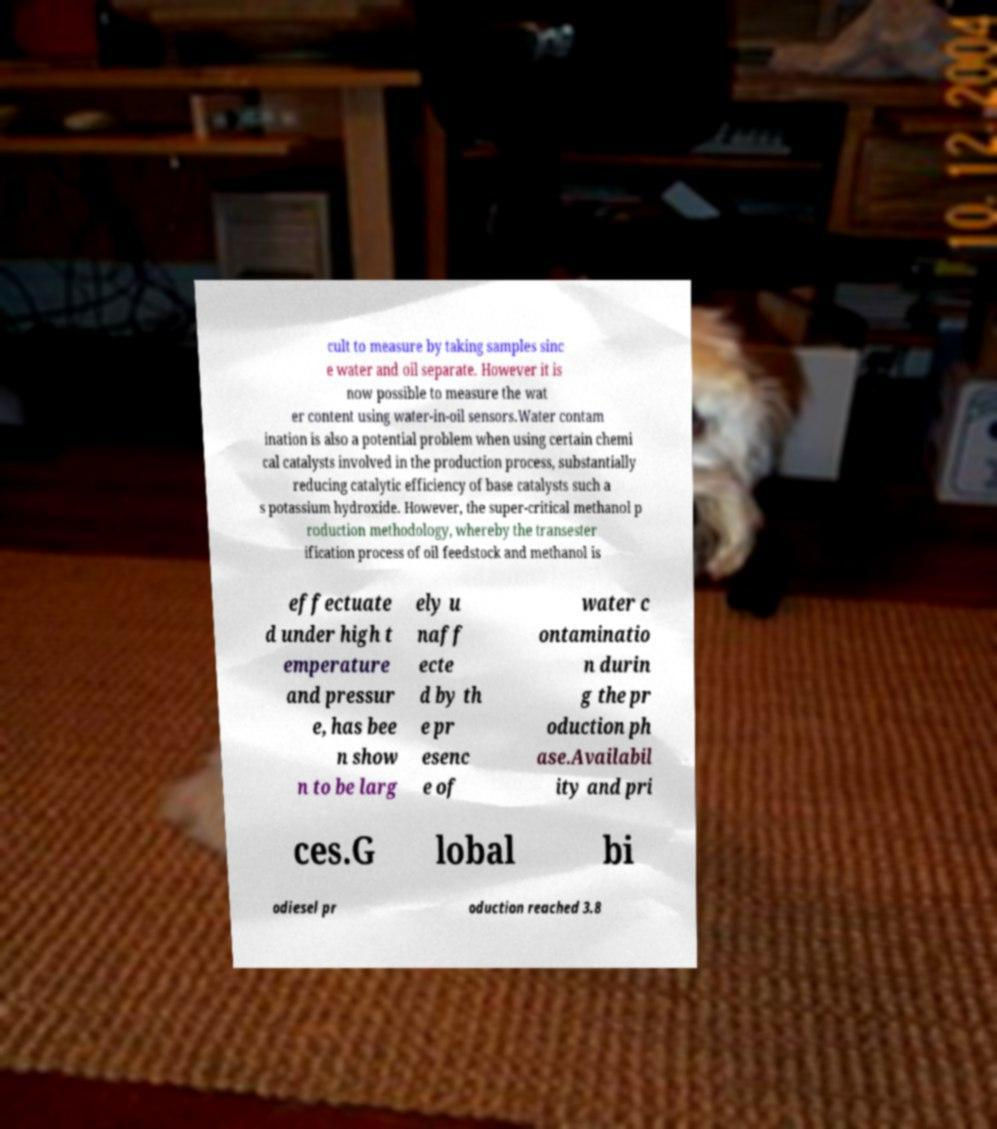There's text embedded in this image that I need extracted. Can you transcribe it verbatim? cult to measure by taking samples sinc e water and oil separate. However it is now possible to measure the wat er content using water-in-oil sensors.Water contam ination is also a potential problem when using certain chemi cal catalysts involved in the production process, substantially reducing catalytic efficiency of base catalysts such a s potassium hydroxide. However, the super-critical methanol p roduction methodology, whereby the transester ification process of oil feedstock and methanol is effectuate d under high t emperature and pressur e, has bee n show n to be larg ely u naff ecte d by th e pr esenc e of water c ontaminatio n durin g the pr oduction ph ase.Availabil ity and pri ces.G lobal bi odiesel pr oduction reached 3.8 